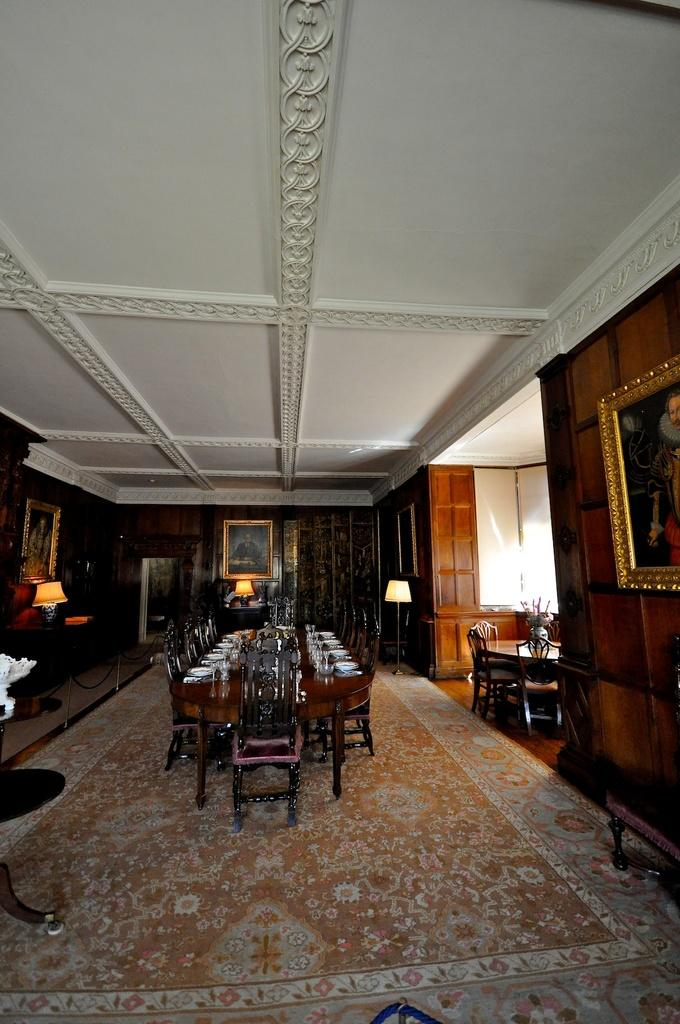What type of furniture can be seen in the image? There are tables and chairs in the image. What decorative items are present in the image? There are flower vases in the image. What items might be used for serving food in the image? There are plates in the image. What items might be used for drinking in the image? There are glasses in the image. What type of floor covering is visible in the image? There is a carpet in the image. What type of lighting is present in the image? There are lamps in the image. What type of wall decorations are present in the image? There are frames attached to the wall in the image. What items can be seen on the table in the image? There are objects on the table in the image. What time of day does the image depict, and how does it relate to the concept of wealth? The image does not depict a specific time of day, and the concept of wealth is not mentioned or implied in the image. What class of society is represented in the image, and how does it relate to the objects on the table? The image does not depict a specific class of society, and the objects on the table do not indicate any particular social class. 